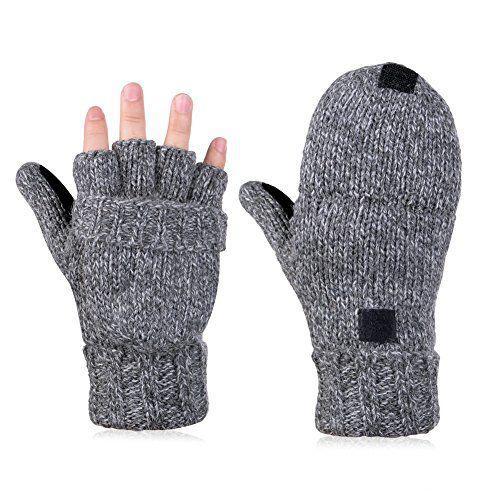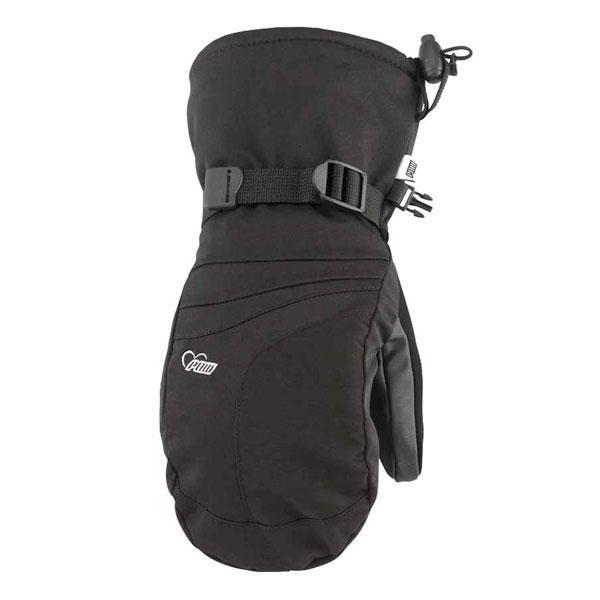The first image is the image on the left, the second image is the image on the right. Given the left and right images, does the statement "One pair of gloves are knit." hold true? Answer yes or no. Yes. The first image is the image on the left, the second image is the image on the right. Evaluate the accuracy of this statement regarding the images: "Mittens are decorated with fur/faux fur and contain colors other than black.". Is it true? Answer yes or no. No. 